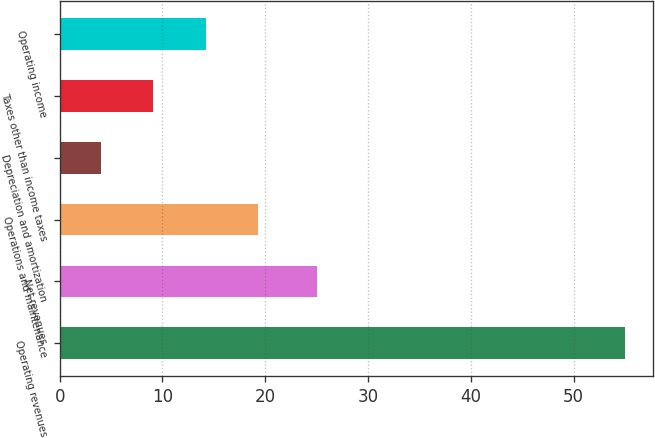Convert chart. <chart><loc_0><loc_0><loc_500><loc_500><bar_chart><fcel>Operating revenues<fcel>Net revenues<fcel>Operations and maintenance<fcel>Depreciation and amortization<fcel>Taxes other than income taxes<fcel>Operating income<nl><fcel>55<fcel>25<fcel>19.3<fcel>4<fcel>9.1<fcel>14.2<nl></chart> 